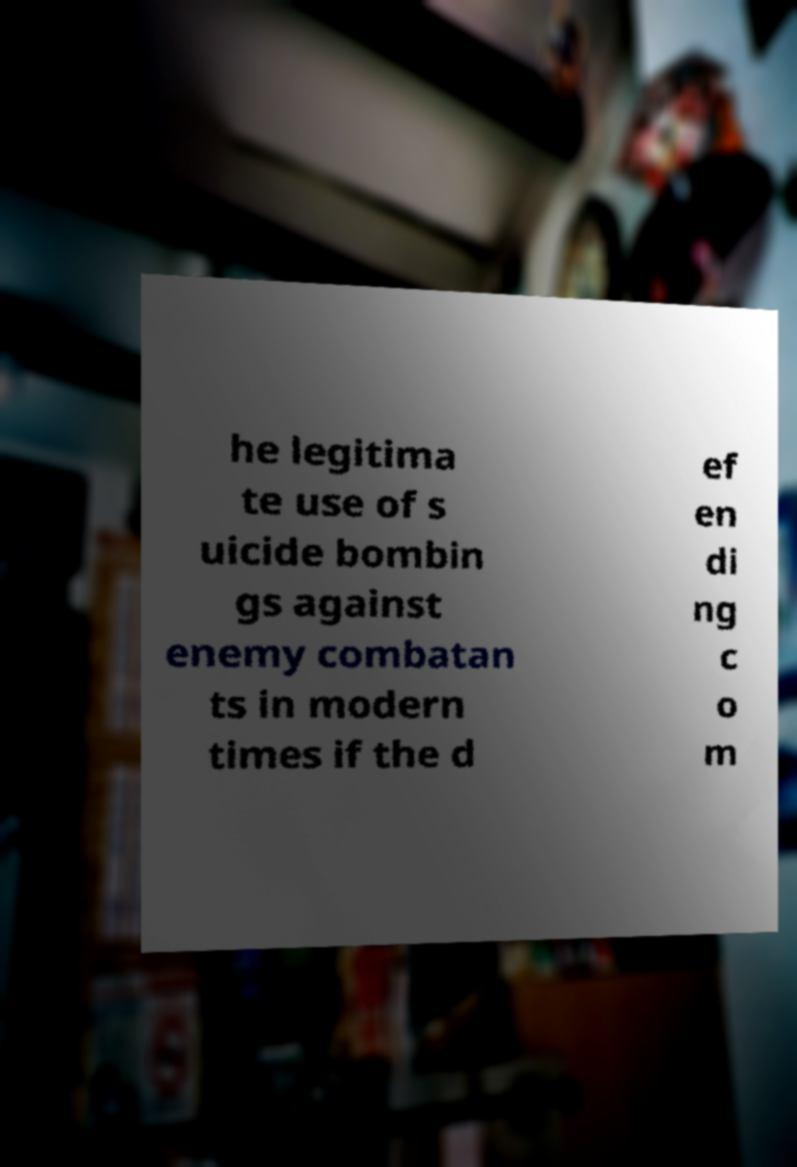There's text embedded in this image that I need extracted. Can you transcribe it verbatim? he legitima te use of s uicide bombin gs against enemy combatan ts in modern times if the d ef en di ng c o m 